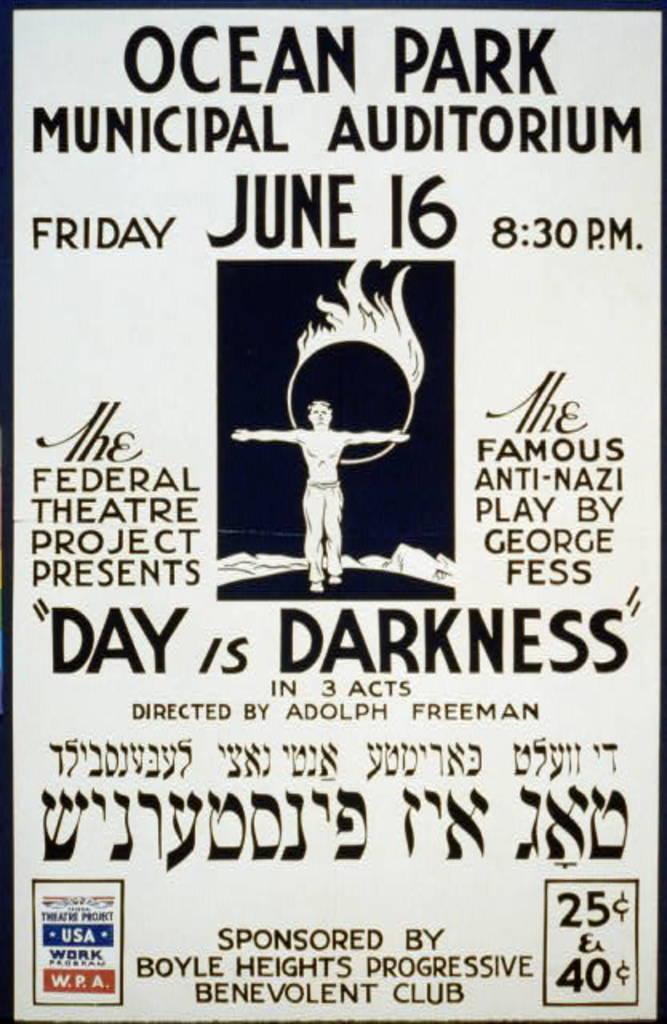What day is this event scheduled for?
Provide a short and direct response. June 16. Who is the director of the act?
Your answer should be compact. Adolph freeman. 